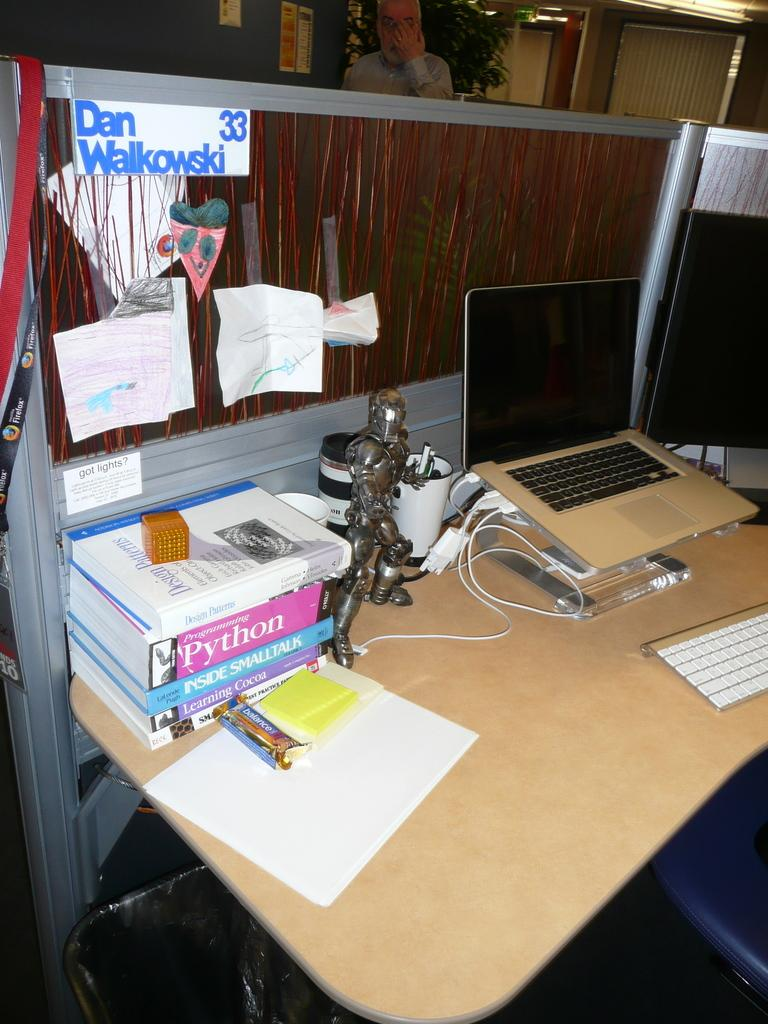What piece of furniture is present in the image? There is a desk in the image. What items can be seen on the desk? There are papers, books, a wire, a toy, and a laptop on the desk. Can you describe the background of the image? There is a plant and a person in the background of the image. What type of bomb is present in the image? There is no bomb present in the image. Is there any oil visible in the image? There is no oil visible in the image. 